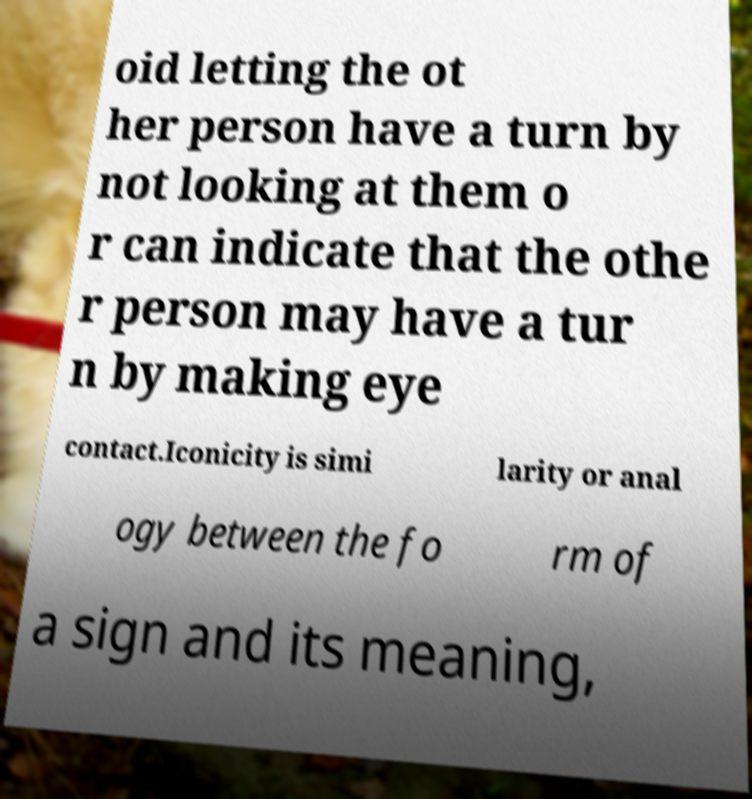Can you accurately transcribe the text from the provided image for me? oid letting the ot her person have a turn by not looking at them o r can indicate that the othe r person may have a tur n by making eye contact.Iconicity is simi larity or anal ogy between the fo rm of a sign and its meaning, 